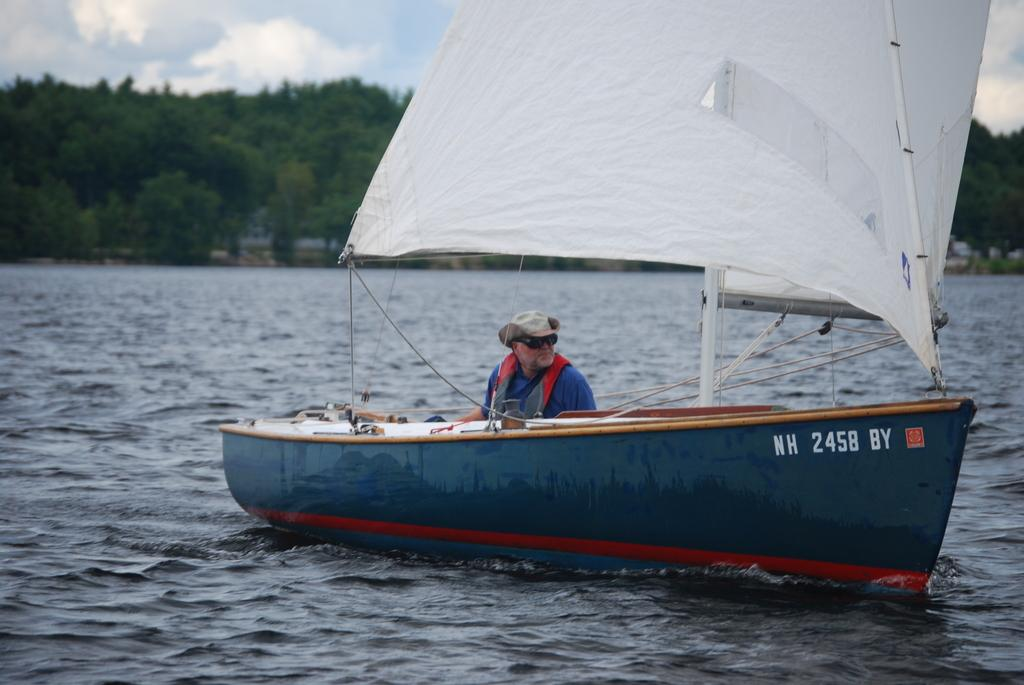What is the main subject of the image? There is a boat in the image. Who is present in the boat? A man is sitting in the boat. What can be seen in the background of the image? There are trees in the background of the image. How would you describe the sky in the image? The sky is covered with clouds. What is visible at the bottom of the image? Water is visible at the bottom of the image. Where is the letter that the man is writing in the image? There is no letter present in the image; the man is simply sitting in the boat. What type of sink can be seen in the image? There is no sink present in the image; it features a boat on water. 